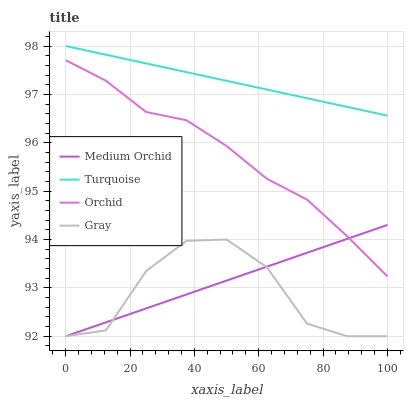Does Medium Orchid have the minimum area under the curve?
Answer yes or no. No. Does Medium Orchid have the maximum area under the curve?
Answer yes or no. No. Is Medium Orchid the smoothest?
Answer yes or no. No. Is Medium Orchid the roughest?
Answer yes or no. No. Does Turquoise have the lowest value?
Answer yes or no. No. Does Medium Orchid have the highest value?
Answer yes or no. No. Is Orchid less than Turquoise?
Answer yes or no. Yes. Is Orchid greater than Gray?
Answer yes or no. Yes. Does Orchid intersect Turquoise?
Answer yes or no. No. 